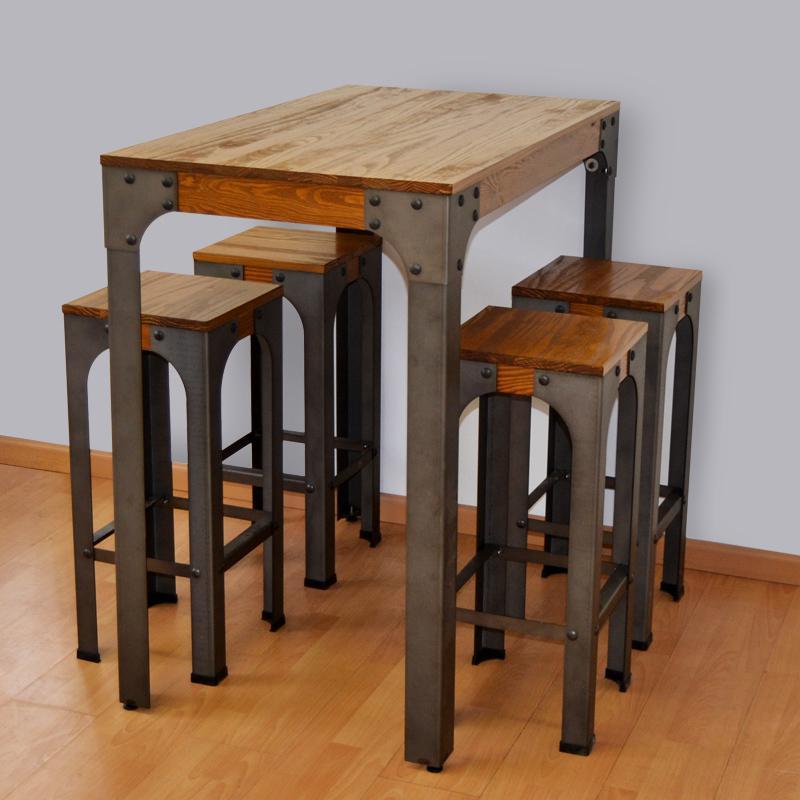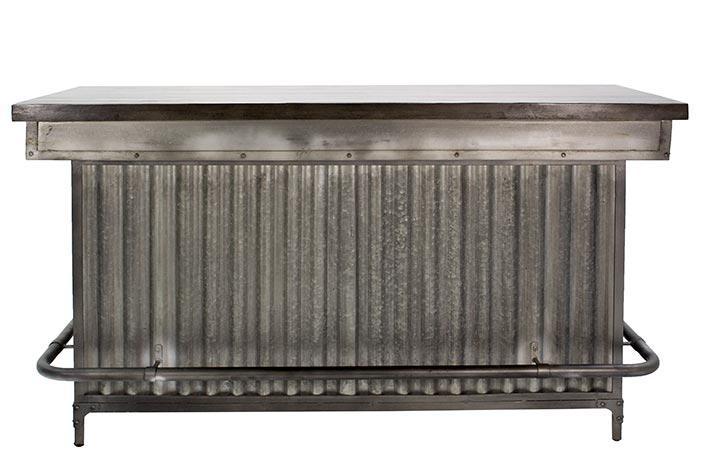The first image is the image on the left, the second image is the image on the right. Analyze the images presented: Is the assertion "There are three green drums, with a wooden table running across the top of the drums." valid? Answer yes or no. No. The first image is the image on the left, the second image is the image on the right. Considering the images on both sides, is "There is a total of three green barrell with a wooden table top." valid? Answer yes or no. No. 